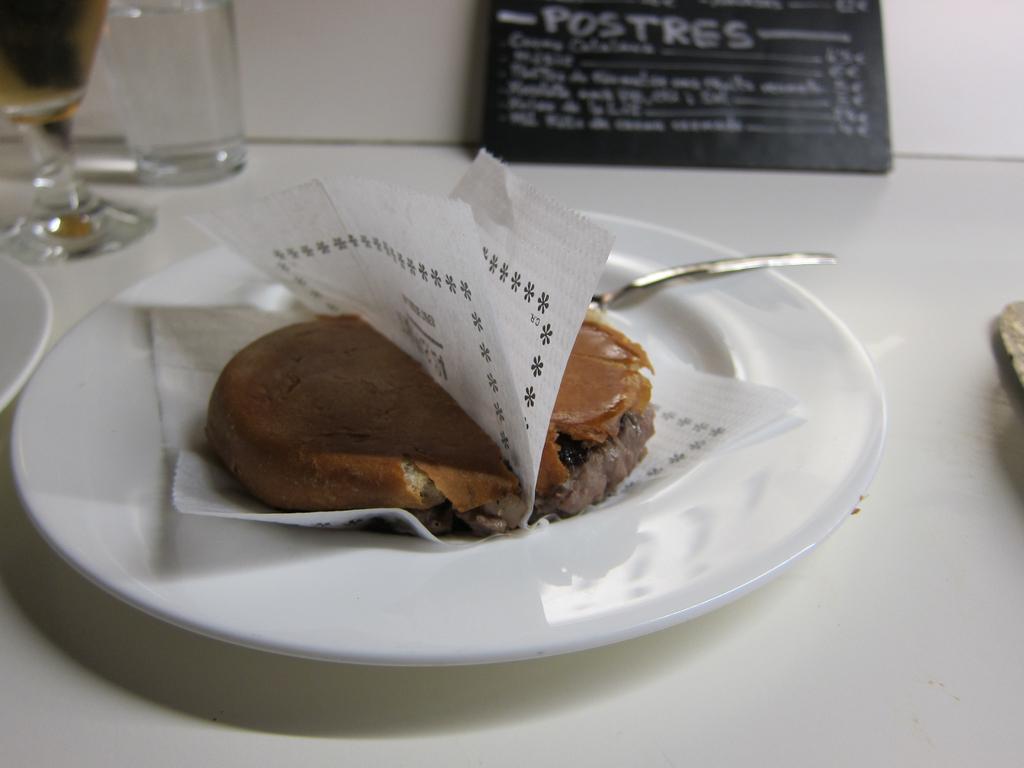How would you summarize this image in a sentence or two? In this image I see the white surface on which there are 2 plates and on this plate I see food which is of brown in color and I see a silver color thing over here and I can also see the white papers and I see 2 glasses over here and I see the black board on which there are words written. 